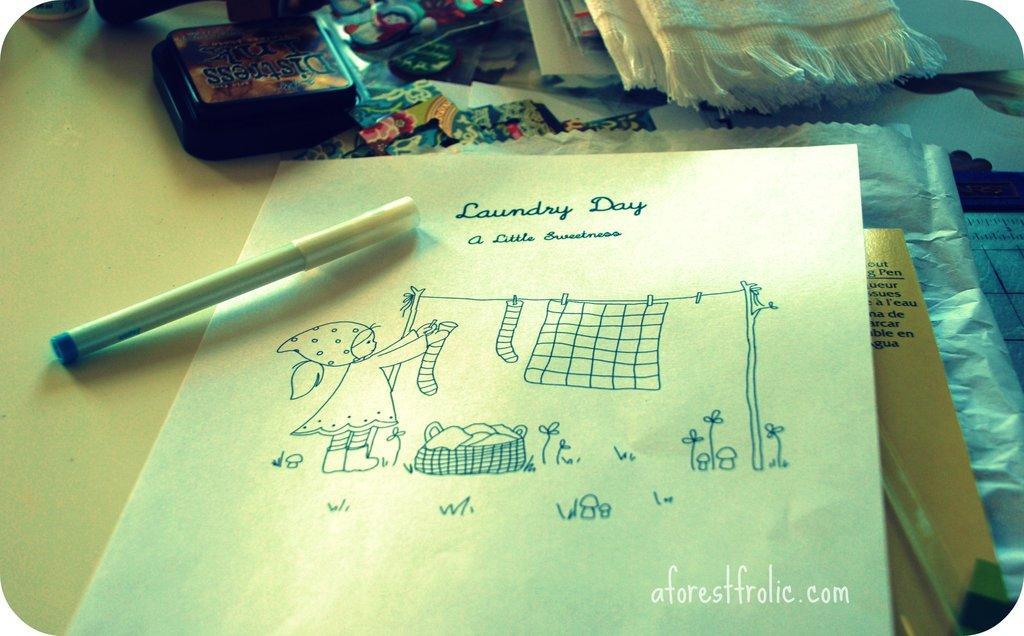In one or two sentences, can you explain what this image depicts? In this picture there is a pen, paper, book, cover, cloth and other objects on the table. In the right bottom there is a text. 